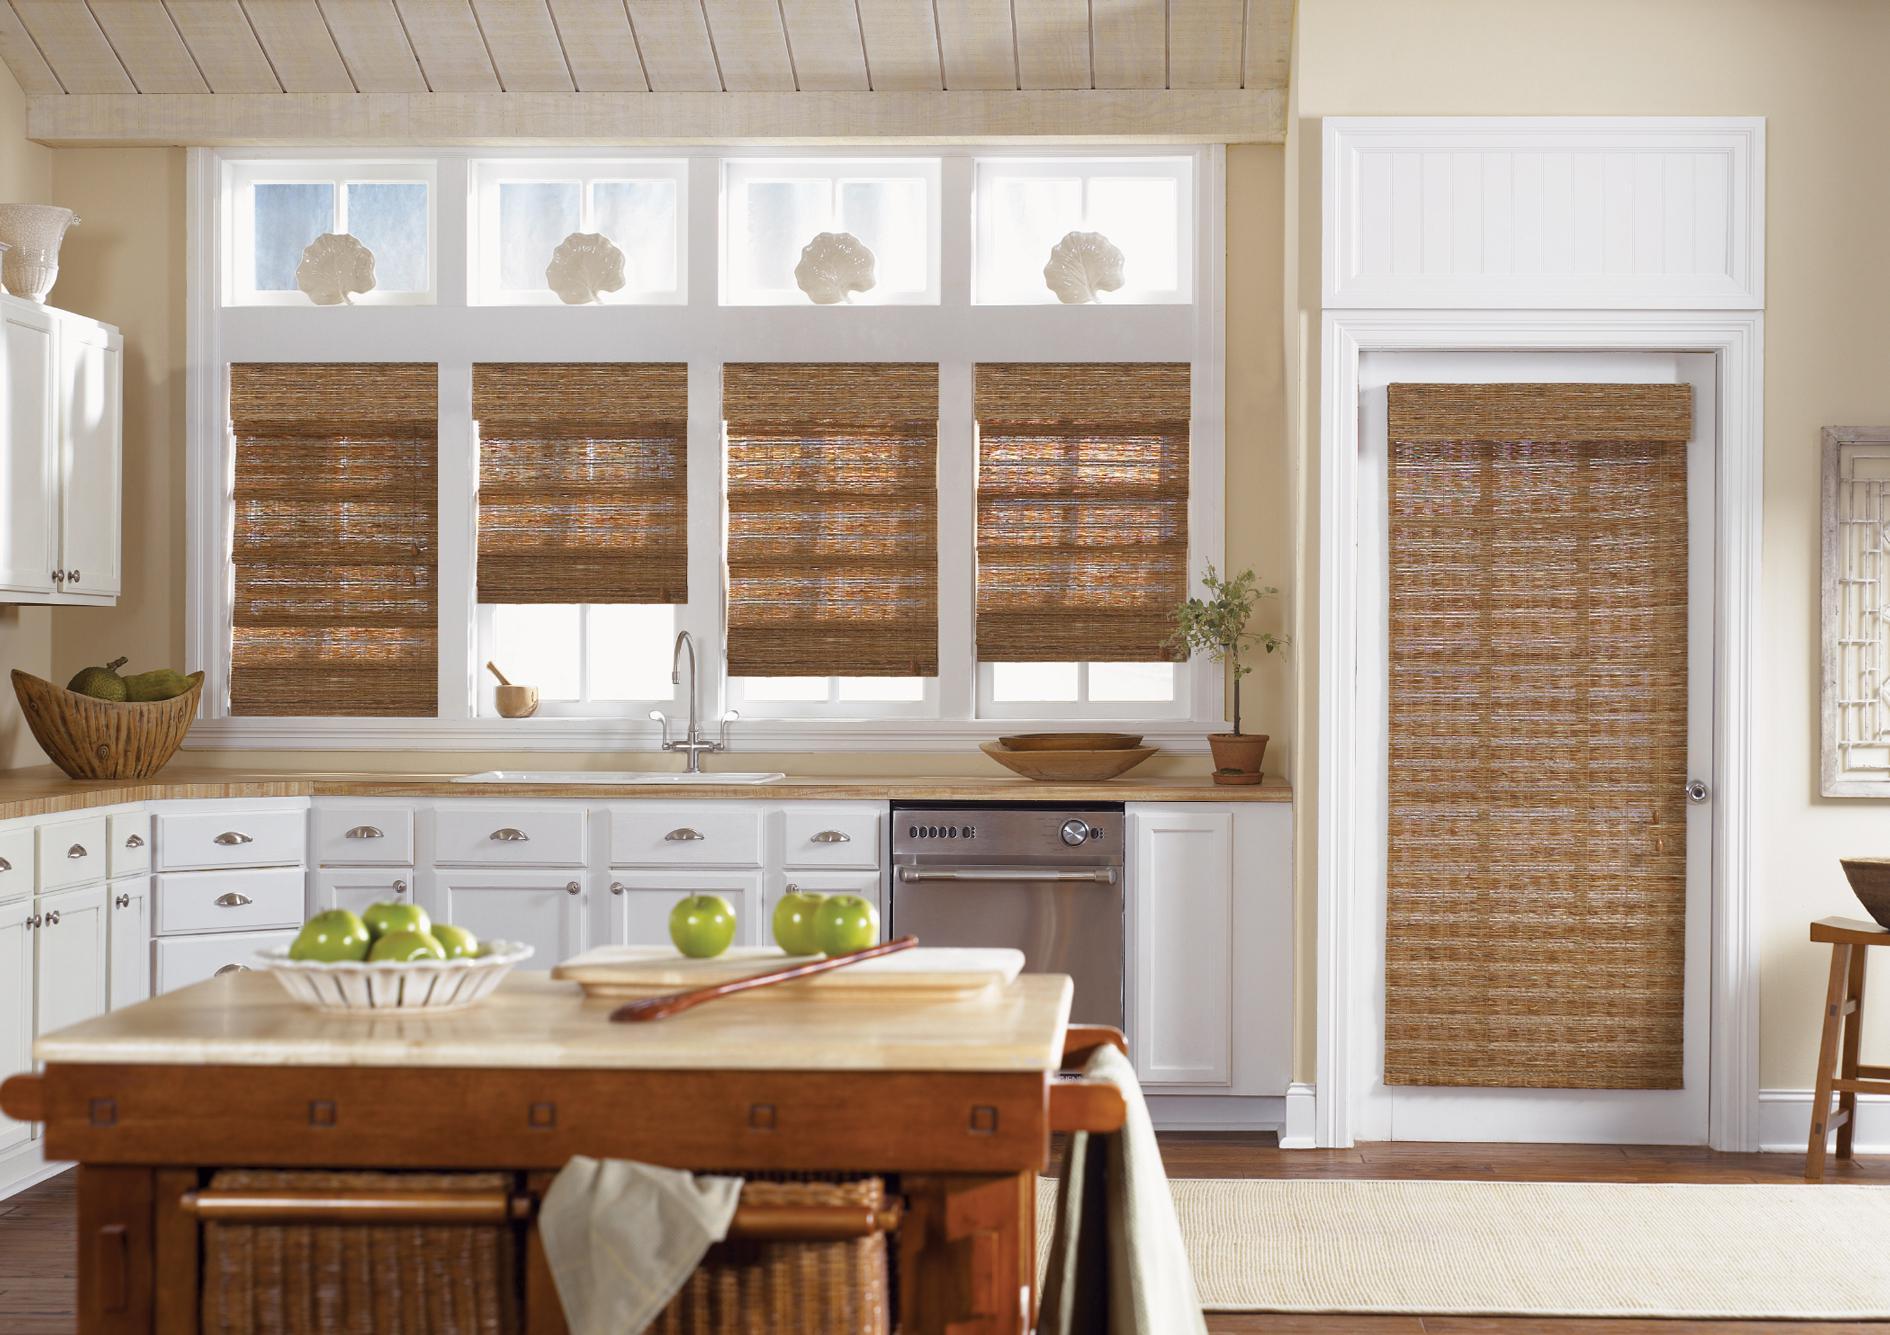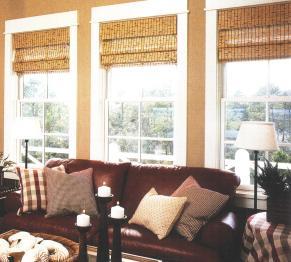The first image is the image on the left, the second image is the image on the right. Considering the images on both sides, is "At least one shade is all the way closed." valid? Answer yes or no. Yes. The first image is the image on the left, the second image is the image on the right. Evaluate the accuracy of this statement regarding the images: "There are six blinds.". Is it true? Answer yes or no. No. 